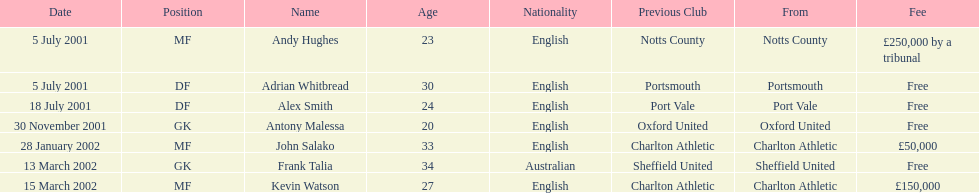Did andy hughes or john salako command the largest fee? Andy Hughes. Could you help me parse every detail presented in this table? {'header': ['Date', 'Position', 'Name', 'Age', 'Nationality', 'Previous Club', 'From', 'Fee'], 'rows': [['5 July 2001', 'MF', 'Andy Hughes', '23', 'English', 'Notts County', 'Notts County', '£250,000 by a tribunal'], ['5 July 2001', 'DF', 'Adrian Whitbread', '30', 'English', 'Portsmouth', 'Portsmouth', 'Free'], ['18 July 2001', 'DF', 'Alex Smith', '24', 'English', 'Port Vale', 'Port Vale', 'Free'], ['30 November 2001', 'GK', 'Antony Malessa', '20', 'English', 'Oxford United', 'Oxford United', 'Free'], ['28 January 2002', 'MF', 'John Salako', '33', 'English', 'Charlton Athletic', 'Charlton Athletic', '£50,000'], ['13 March 2002', 'GK', 'Frank Talia', '34', 'Australian', 'Sheffield United', 'Sheffield United', 'Free'], ['15 March 2002', 'MF', 'Kevin Watson', '27', 'English', 'Charlton Athletic', 'Charlton Athletic', '£150,000']]} 